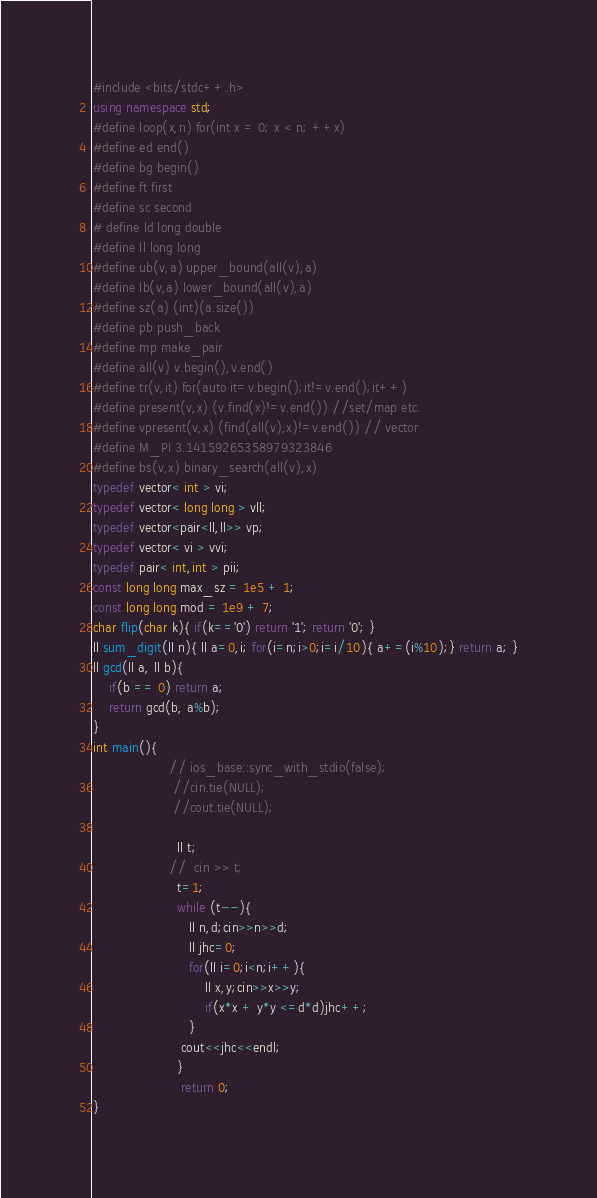<code> <loc_0><loc_0><loc_500><loc_500><_C++_>#include <bits/stdc++.h>
using namespace std;
#define loop(x,n) for(int x = 0; x < n; ++x)
#define ed end()  
#define bg begin()
#define ft first
#define sc second
# define ld long double
#define ll long long
#define ub(v,a) upper_bound(all(v),a)
#define lb(v,a) lower_bound(all(v),a)
#define sz(a) (int)(a.size())
#define pb push_back
#define mp make_pair
#define all(v) v.begin(),v.end()
#define tr(v,it) for(auto it=v.begin();it!=v.end();it++)
#define present(v,x) (v.find(x)!=v.end()) //set/map etc.
#define vpresent(v,x) (find(all(v),x)!=v.end()) // vector
#define M_PI 3.14159265358979323846
#define bs(v,x) binary_search(all(v),x)
typedef vector< int > vi;
typedef vector< long long > vll;
typedef vector<pair<ll,ll>> vp;
typedef vector< vi > vvi;
typedef pair< int,int > pii;
const long long max_sz = 1e5 + 1;
const long long mod = 1e9 + 7;
char flip(char k){ if(k=='0') return '1'; return '0'; }
ll sum_digit(ll n){ ll a=0,i; for(i=n;i>0;i=i/10){ a+=(i%10);} return a; }
ll gcd(ll a, ll b){
	if(b == 0) return a;
	return gcd(b, a%b);
}
int main(){
                   // ios_base::sync_with_stdio(false);
                    //cin.tie(NULL);
                    //cout.tie(NULL);
 
                     ll t;
                   //  cin >> t;
                     t=1;
                     while (t--){
                        ll n,d;cin>>n>>d;
                        ll jhc=0;
                        for(ll i=0;i<n;i++){
                            ll x,y;cin>>x>>y;
                            if(x*x + y*y <=d*d)jhc++;
                        }
                      cout<<jhc<<endl;
                     }
                      return 0;
}</code> 